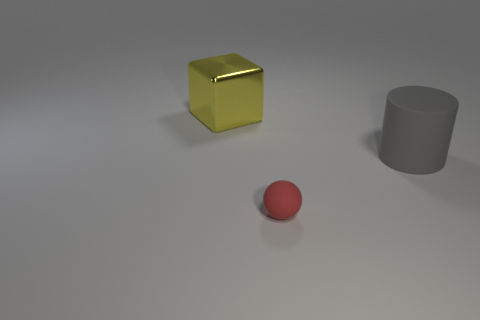Is there anything that indicates the scale or size of the objects? There are no clear indicators of scale, such as familiar objects for reference or a background environment. The objects' sizes can only be inferred relative to each other, with the yellow cube being the largest, the grey cylinder medium, and the red sphere small. 